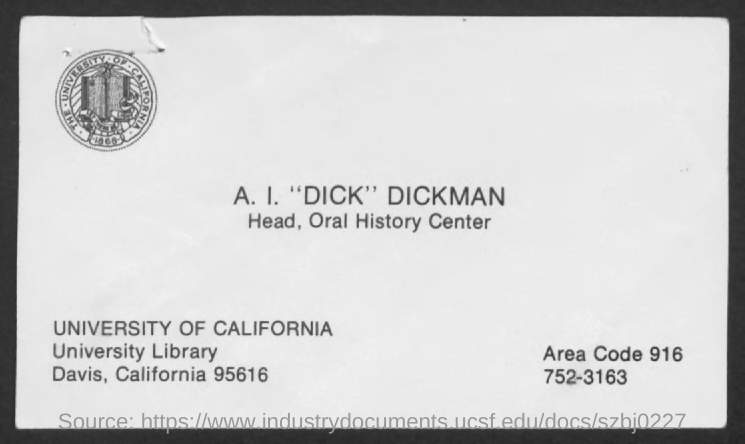To Whom is this letter addressed to?
Give a very brief answer. A. I. "DICK" DICKMAN. Who is A. I. "Dick" Dickman?
Provide a succinct answer. Head, Oral History Center. What is the Area Code?
Offer a very short reply. 916. What is the Location of University of California?
Give a very brief answer. Davis, california 95616. 